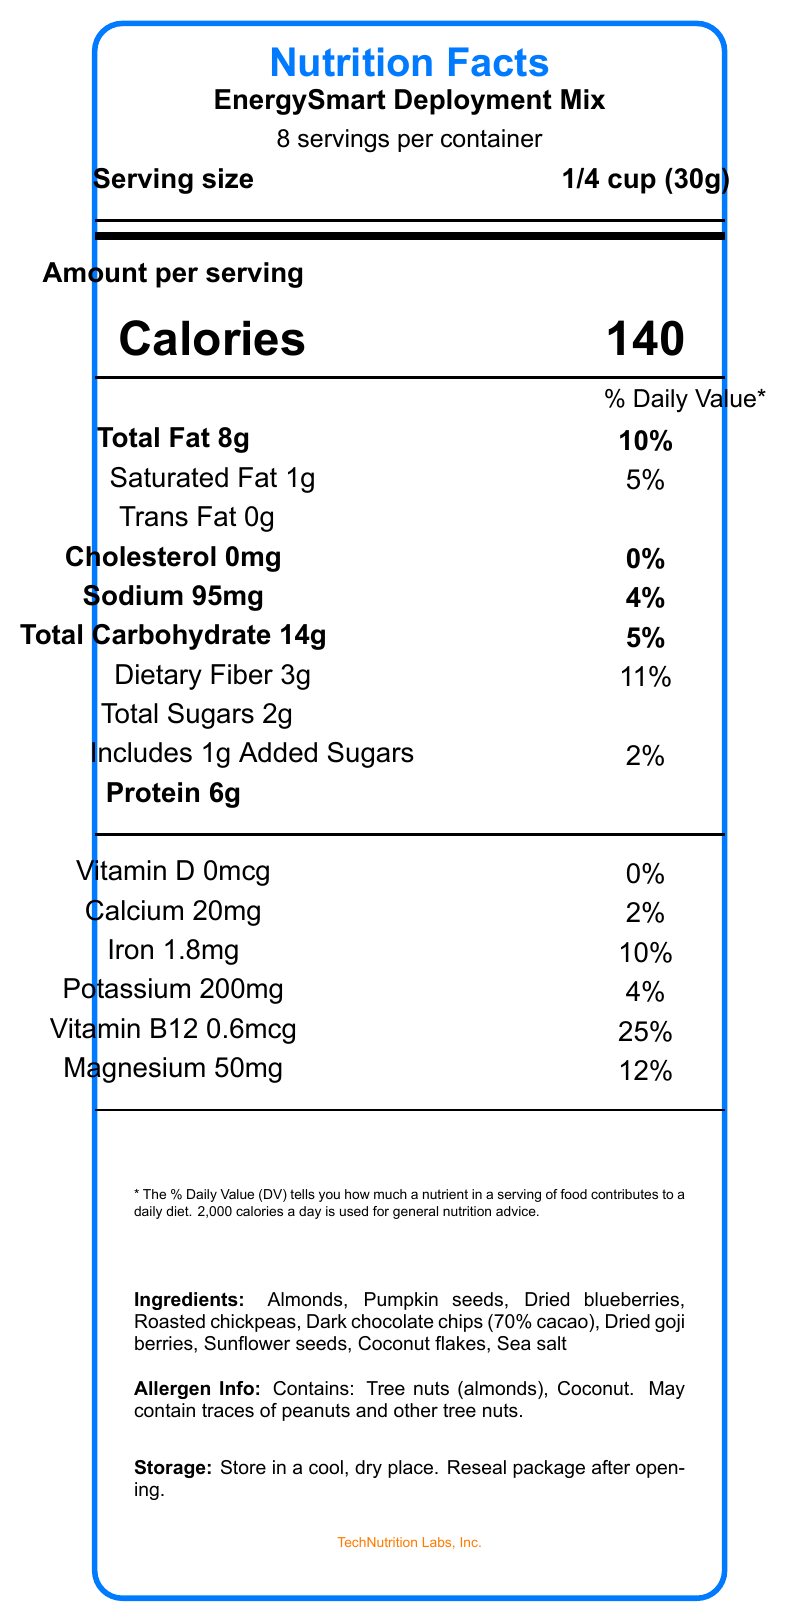What is the serving size of EnergySmart Deployment Mix? The serving size is explicitly mentioned at the top part of the document.
Answer: 1/4 cup (30g) How many calories are in one serving of EnergySmart Deployment Mix? The document states “Calories 140” in the central portion under "Amount per serving."
Answer: 140 calories What is the total fat content per serving? The total fat content is listed under Amount per serving in the "Total Fat" section.
Answer: 8g What percentage of the daily value for Vitamin B12 is provided by one serving? The daily value percentage for Vitamin B12 is shown as 25% at the bottom of the vitamins and minerals section.
Answer: 25% Which company manufactures EnergySmart Deployment Mix? The manufacturer's information is found at the bottom of the document where it states "TechNutrition Labs, Inc."
Answer: TechNutrition Labs, Inc. What are the key benefits of this product? A. Low sodium B. Rich in antioxidants C. High fiber D. Supports heart health The document lists as key benefits "Rich in antioxidants from blueberries and goji berries" and "Balanced mix of complex carbohydrates and fiber for steady blood sugar levels."
Answer: B, C Which nutrient has the highest percentage of the daily value?  I. Vitamin D II. Calcium III. Vitamin B12  IV. Magnesium Vitamin B12 has the highest daily value listed, which is 25%.
Answer: III Does this product contain any trans fat? The document clearly states "Trans Fat 0g."
Answer: No Is this product appropriate for someone with a tree nut allergy? The allergen information mentions the presence of tree nuts (almonds).
Answer: No Summarize the main idea of the Nutrition Facts Label for EnergySmart Deployment Mix. This summary includes key points about the product description, nutritional content, ingredients, and purpose.
Answer: The EnergySmart Deployment Mix is a nutrient-dense snack designed for project managers working on autonomous system deployments. It is high in protein and healthy fats, antioxidants, and key vitamins and minerals to sustain energy, mental clarity, and support cognitive function and stress management. The label includes serving size, nutritional content, ingredients, allergen info, and storage instructions. What is the exact amount of added sugars in one serving? The addition of 1g of sugar is explicitly mentioned in the document under "Includes 1g Added Sugars."
Answer: 1g What type of fats primarily constitute the total fat in the mix: saturated or trans fats? The document specifies 1g of saturated fat and 0g of trans fat, making saturated fat the primary type.
Answer: Saturated If someone consumes the entire container, how much sodium will they consume? There are 8 servings per container, each serving contains 95mg of sodium. 95mg/serving * 8 servings = 760mg total.
Answer: 760mg How much dietary fiber does the EnergySmart Deployment Mix provide per serving? The dietary fiber content is stated directly in the document under "Dietary Fiber 3g".
Answer: 3g Can we determine if this product is gluten-free? The document does not provide information about whether the product is gluten-free.
Answer: Not enough information 